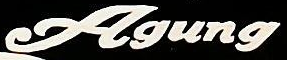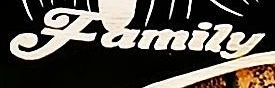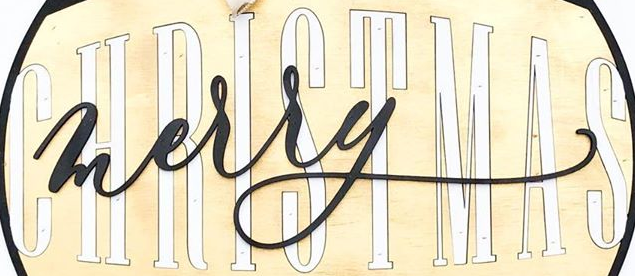What words are shown in these images in order, separated by a semicolon? Agung; Family; CHRISTMAS 